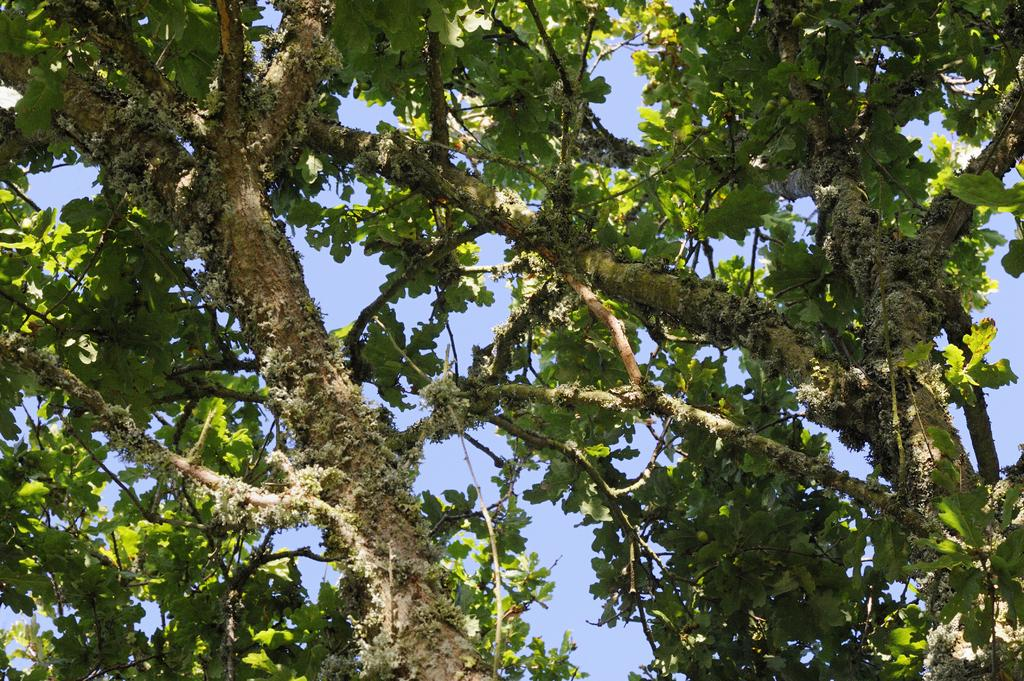What type of vegetation can be seen in the image? There are trees in the image. What features do the trees have? The trees have leaves and branches. What type of cheese is hanging from the branches of the trees in the image? There is no cheese present in the image; it only features trees with leaves and branches. 